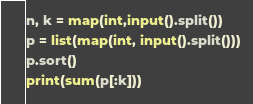<code> <loc_0><loc_0><loc_500><loc_500><_Python_>n, k = map(int,input().split())
p = list(map(int, input().split()))
p.sort()
print(sum(p[:k]))</code> 